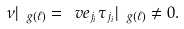Convert formula to latex. <formula><loc_0><loc_0><loc_500><loc_500>\nu | _ { \ g ( \ell ) } = \ v e _ { j _ { i } } \tau _ { j _ { i } } | _ { \ g ( \ell ) } \ne 0 .</formula> 